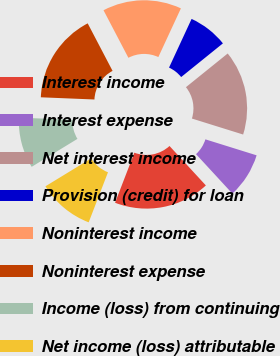Convert chart. <chart><loc_0><loc_0><loc_500><loc_500><pie_chart><fcel>Interest income<fcel>Interest expense<fcel>Net interest income<fcel>Provision (credit) for loan<fcel>Noninterest income<fcel>Noninterest expense<fcel>Income (loss) from continuing<fcel>Net income (loss) attributable<nl><fcel>17.71%<fcel>8.33%<fcel>15.62%<fcel>7.29%<fcel>14.58%<fcel>16.67%<fcel>9.38%<fcel>10.42%<nl></chart> 